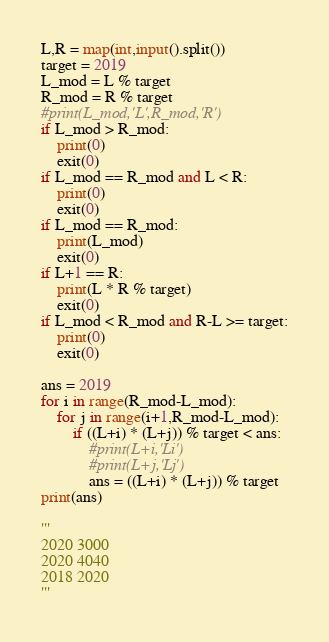Convert code to text. <code><loc_0><loc_0><loc_500><loc_500><_Python_>L,R = map(int,input().split())
target = 2019
L_mod = L % target
R_mod = R % target
#print(L_mod,'L',R_mod,'R')
if L_mod > R_mod:
    print(0)
    exit(0)
if L_mod == R_mod and L < R:
    print(0)
    exit(0)
if L_mod == R_mod:
    print(L_mod)
    exit(0)
if L+1 == R:
    print(L * R % target)
    exit(0)
if L_mod < R_mod and R-L >= target:
    print(0)
    exit(0)

ans = 2019
for i in range(R_mod-L_mod):
    for j in range(i+1,R_mod-L_mod):
        if ((L+i) * (L+j)) % target < ans:
            #print(L+i,'Li')
            #print(L+j,'Lj')
            ans = ((L+i) * (L+j)) % target
print(ans)

'''
2020 3000
2020 4040
2018 2020
'''


</code> 